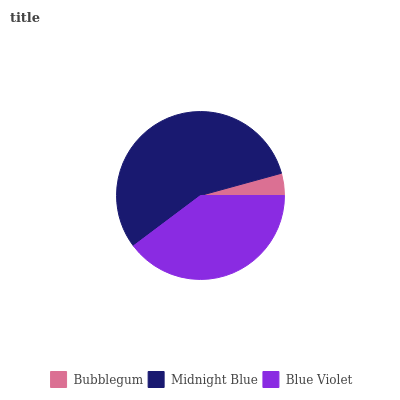Is Bubblegum the minimum?
Answer yes or no. Yes. Is Midnight Blue the maximum?
Answer yes or no. Yes. Is Blue Violet the minimum?
Answer yes or no. No. Is Blue Violet the maximum?
Answer yes or no. No. Is Midnight Blue greater than Blue Violet?
Answer yes or no. Yes. Is Blue Violet less than Midnight Blue?
Answer yes or no. Yes. Is Blue Violet greater than Midnight Blue?
Answer yes or no. No. Is Midnight Blue less than Blue Violet?
Answer yes or no. No. Is Blue Violet the high median?
Answer yes or no. Yes. Is Blue Violet the low median?
Answer yes or no. Yes. Is Midnight Blue the high median?
Answer yes or no. No. Is Bubblegum the low median?
Answer yes or no. No. 